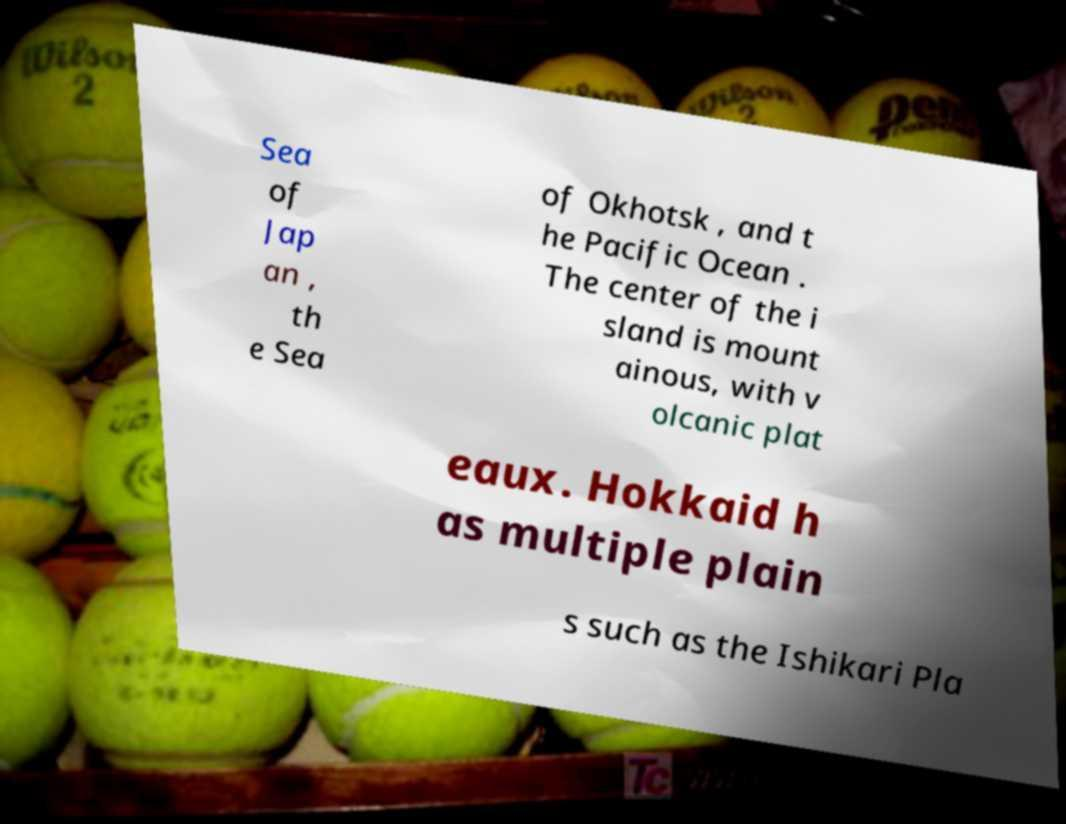For documentation purposes, I need the text within this image transcribed. Could you provide that? Sea of Jap an , th e Sea of Okhotsk , and t he Pacific Ocean . The center of the i sland is mount ainous, with v olcanic plat eaux. Hokkaid h as multiple plain s such as the Ishikari Pla 